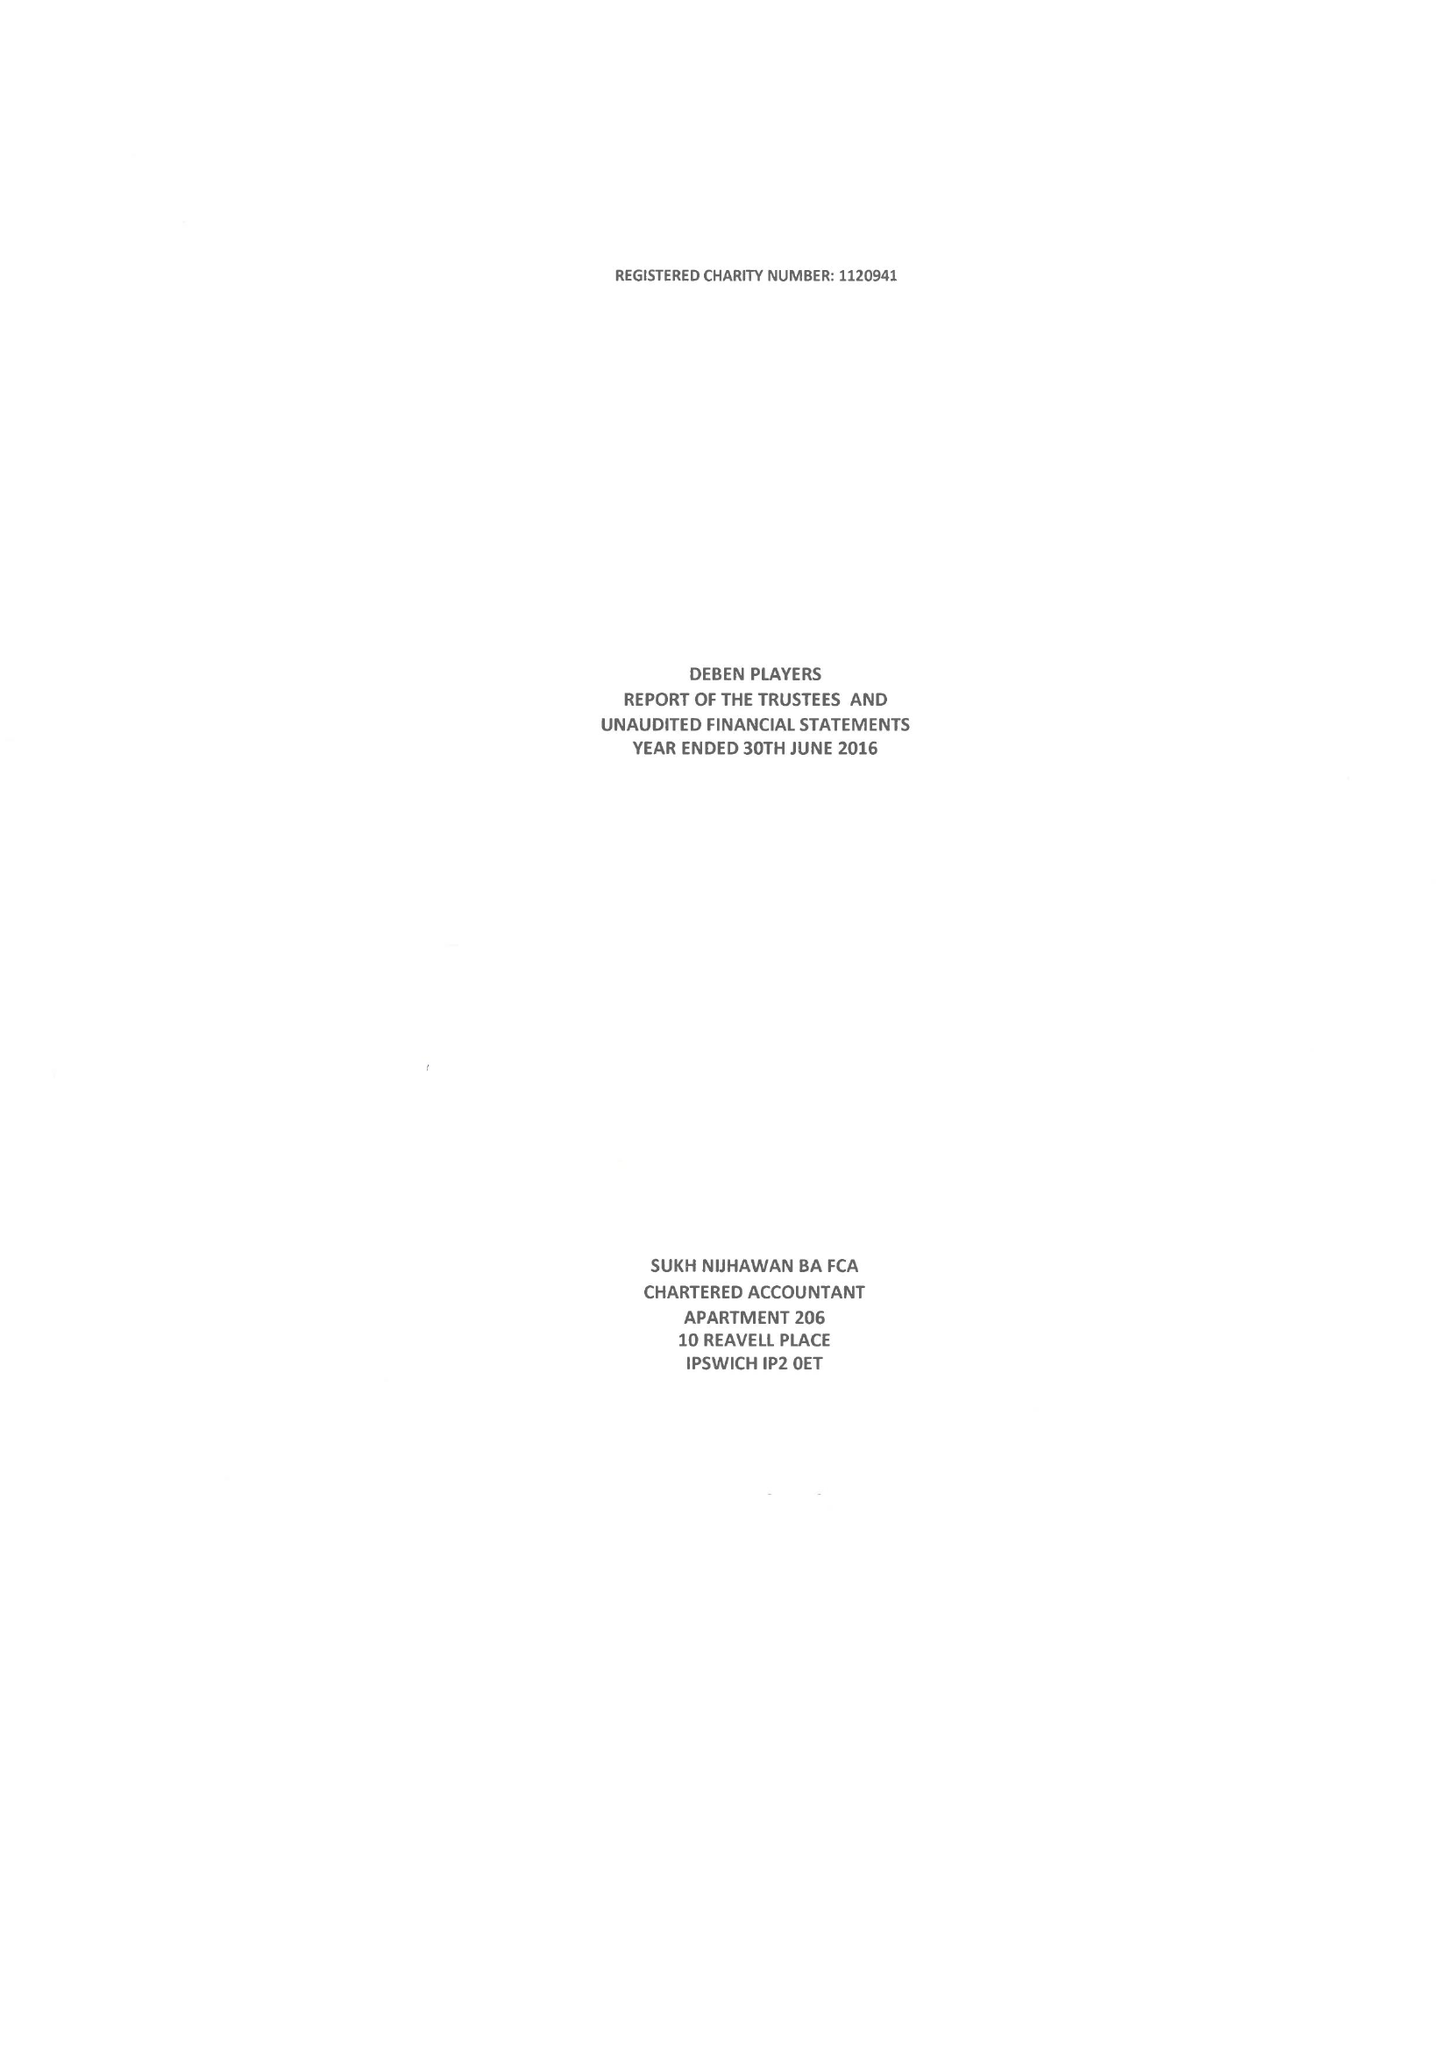What is the value for the spending_annually_in_british_pounds?
Answer the question using a single word or phrase. 24874.00 